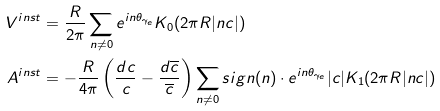<formula> <loc_0><loc_0><loc_500><loc_500>V ^ { i n s t } & = \frac { R } { 2 \pi } \sum _ { n \ne 0 } e ^ { i n \theta _ { \gamma _ { e } } } K _ { 0 } ( 2 \pi R | n c | ) \\ A ^ { i n s t } & = - \frac { R } { 4 \pi } \left ( \frac { d c } { c } - \frac { d \overline { c } } { \overline { c } } \right ) \sum _ { n \ne 0 } s i g n ( n ) \cdot e ^ { i n \theta _ { \gamma _ { e } } } | c | K _ { 1 } ( 2 \pi R | n c | )</formula> 